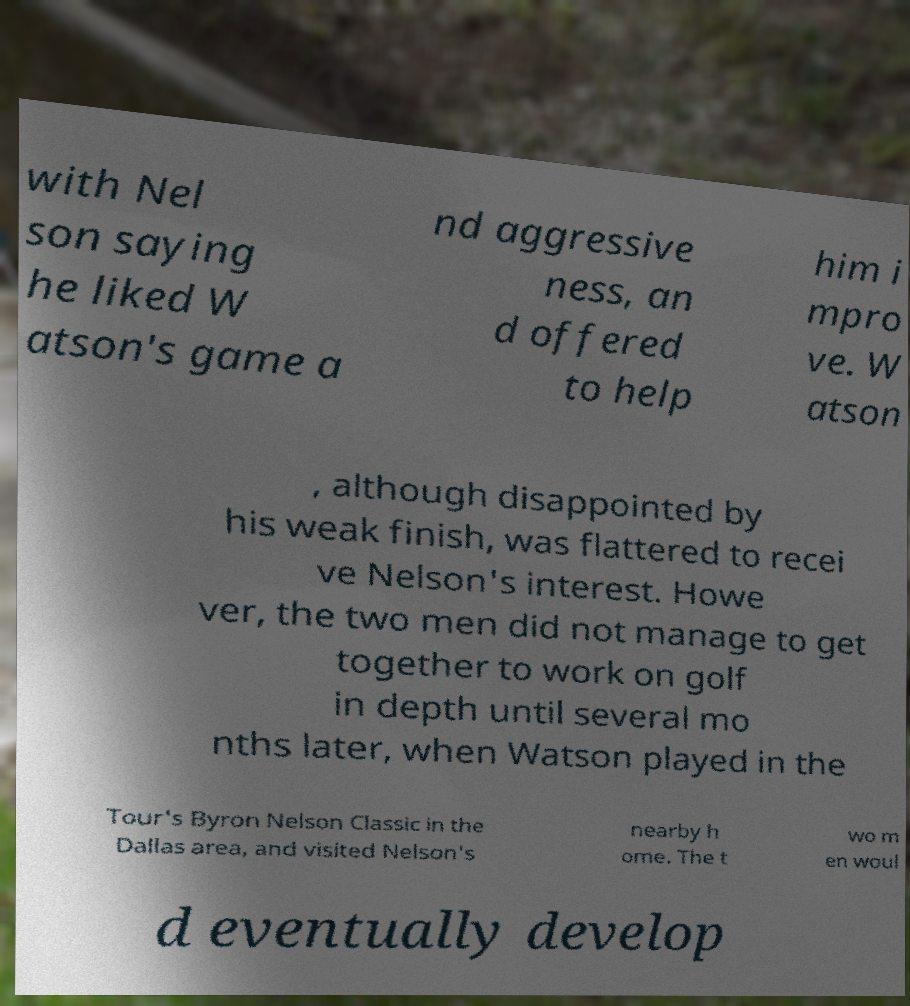Can you accurately transcribe the text from the provided image for me? with Nel son saying he liked W atson's game a nd aggressive ness, an d offered to help him i mpro ve. W atson , although disappointed by his weak finish, was flattered to recei ve Nelson's interest. Howe ver, the two men did not manage to get together to work on golf in depth until several mo nths later, when Watson played in the Tour's Byron Nelson Classic in the Dallas area, and visited Nelson's nearby h ome. The t wo m en woul d eventually develop 